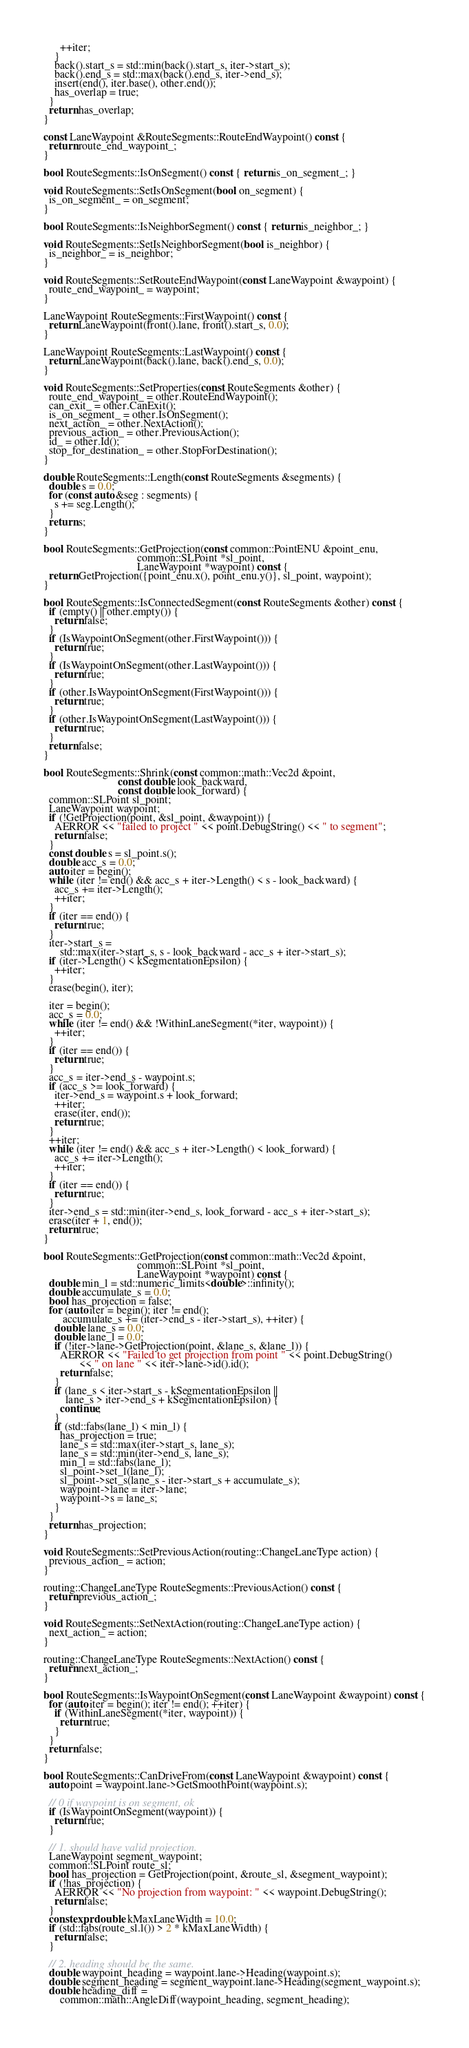<code> <loc_0><loc_0><loc_500><loc_500><_C++_>      ++iter;
    }
    back().start_s = std::min(back().start_s, iter->start_s);
    back().end_s = std::max(back().end_s, iter->end_s);
    insert(end(), iter.base(), other.end());
    has_overlap = true;
  }
  return has_overlap;
}

const LaneWaypoint &RouteSegments::RouteEndWaypoint() const {
  return route_end_waypoint_;
}

bool RouteSegments::IsOnSegment() const { return is_on_segment_; }

void RouteSegments::SetIsOnSegment(bool on_segment) {
  is_on_segment_ = on_segment;
}

bool RouteSegments::IsNeighborSegment() const { return is_neighbor_; }

void RouteSegments::SetIsNeighborSegment(bool is_neighbor) {
  is_neighbor_ = is_neighbor;
}

void RouteSegments::SetRouteEndWaypoint(const LaneWaypoint &waypoint) {
  route_end_waypoint_ = waypoint;
}

LaneWaypoint RouteSegments::FirstWaypoint() const {
  return LaneWaypoint(front().lane, front().start_s, 0.0);
}

LaneWaypoint RouteSegments::LastWaypoint() const {
  return LaneWaypoint(back().lane, back().end_s, 0.0);
}

void RouteSegments::SetProperties(const RouteSegments &other) {
  route_end_waypoint_ = other.RouteEndWaypoint();
  can_exit_ = other.CanExit();
  is_on_segment_ = other.IsOnSegment();
  next_action_ = other.NextAction();
  previous_action_ = other.PreviousAction();
  id_ = other.Id();
  stop_for_destination_ = other.StopForDestination();
}

double RouteSegments::Length(const RouteSegments &segments) {
  double s = 0.0;
  for (const auto &seg : segments) {
    s += seg.Length();
  }
  return s;
}

bool RouteSegments::GetProjection(const common::PointENU &point_enu,
                                  common::SLPoint *sl_point,
                                  LaneWaypoint *waypoint) const {
  return GetProjection({point_enu.x(), point_enu.y()}, sl_point, waypoint);
}

bool RouteSegments::IsConnectedSegment(const RouteSegments &other) const {
  if (empty() || other.empty()) {
    return false;
  }
  if (IsWaypointOnSegment(other.FirstWaypoint())) {
    return true;
  }
  if (IsWaypointOnSegment(other.LastWaypoint())) {
    return true;
  }
  if (other.IsWaypointOnSegment(FirstWaypoint())) {
    return true;
  }
  if (other.IsWaypointOnSegment(LastWaypoint())) {
    return true;
  }
  return false;
}

bool RouteSegments::Shrink(const common::math::Vec2d &point,
                           const double look_backward,
                           const double look_forward) {
  common::SLPoint sl_point;
  LaneWaypoint waypoint;
  if (!GetProjection(point, &sl_point, &waypoint)) {
    AERROR << "failed to project " << point.DebugString() << " to segment";
    return false;
  }
  const double s = sl_point.s();
  double acc_s = 0.0;
  auto iter = begin();
  while (iter != end() && acc_s + iter->Length() < s - look_backward) {
    acc_s += iter->Length();
    ++iter;
  }
  if (iter == end()) {
    return true;
  }
  iter->start_s =
      std::max(iter->start_s, s - look_backward - acc_s + iter->start_s);
  if (iter->Length() < kSegmentationEpsilon) {
    ++iter;
  }
  erase(begin(), iter);

  iter = begin();
  acc_s = 0.0;
  while (iter != end() && !WithinLaneSegment(*iter, waypoint)) {
    ++iter;
  }
  if (iter == end()) {
    return true;
  }
  acc_s = iter->end_s - waypoint.s;
  if (acc_s >= look_forward) {
    iter->end_s = waypoint.s + look_forward;
    ++iter;
    erase(iter, end());
    return true;
  }
  ++iter;
  while (iter != end() && acc_s + iter->Length() < look_forward) {
    acc_s += iter->Length();
    ++iter;
  }
  if (iter == end()) {
    return true;
  }
  iter->end_s = std::min(iter->end_s, look_forward - acc_s + iter->start_s);
  erase(iter + 1, end());
  return true;
}

bool RouteSegments::GetProjection(const common::math::Vec2d &point,
                                  common::SLPoint *sl_point,
                                  LaneWaypoint *waypoint) const {
  double min_l = std::numeric_limits<double>::infinity();
  double accumulate_s = 0.0;
  bool has_projection = false;
  for (auto iter = begin(); iter != end();
       accumulate_s += (iter->end_s - iter->start_s), ++iter) {
    double lane_s = 0.0;
    double lane_l = 0.0;
    if (!iter->lane->GetProjection(point, &lane_s, &lane_l)) {
      AERROR << "Failed to get projection from point " << point.DebugString()
             << " on lane " << iter->lane->id().id();
      return false;
    }
    if (lane_s < iter->start_s - kSegmentationEpsilon ||
        lane_s > iter->end_s + kSegmentationEpsilon) {
      continue;
    }
    if (std::fabs(lane_l) < min_l) {
      has_projection = true;
      lane_s = std::max(iter->start_s, lane_s);
      lane_s = std::min(iter->end_s, lane_s);
      min_l = std::fabs(lane_l);
      sl_point->set_l(lane_l);
      sl_point->set_s(lane_s - iter->start_s + accumulate_s);
      waypoint->lane = iter->lane;
      waypoint->s = lane_s;
    }
  }
  return has_projection;
}

void RouteSegments::SetPreviousAction(routing::ChangeLaneType action) {
  previous_action_ = action;
}

routing::ChangeLaneType RouteSegments::PreviousAction() const {
  return previous_action_;
}

void RouteSegments::SetNextAction(routing::ChangeLaneType action) {
  next_action_ = action;
}

routing::ChangeLaneType RouteSegments::NextAction() const {
  return next_action_;
}

bool RouteSegments::IsWaypointOnSegment(const LaneWaypoint &waypoint) const {
  for (auto iter = begin(); iter != end(); ++iter) {
    if (WithinLaneSegment(*iter, waypoint)) {
      return true;
    }
  }
  return false;
}

bool RouteSegments::CanDriveFrom(const LaneWaypoint &waypoint) const {
  auto point = waypoint.lane->GetSmoothPoint(waypoint.s);

  // 0 if waypoint is on segment, ok
  if (IsWaypointOnSegment(waypoint)) {
    return true;
  }

  // 1. should have valid projection.
  LaneWaypoint segment_waypoint;
  common::SLPoint route_sl;
  bool has_projection = GetProjection(point, &route_sl, &segment_waypoint);
  if (!has_projection) {
    AERROR << "No projection from waypoint: " << waypoint.DebugString();
    return false;
  }
  constexpr double kMaxLaneWidth = 10.0;
  if (std::fabs(route_sl.l()) > 2 * kMaxLaneWidth) {
    return false;
  }

  // 2. heading should be the same.
  double waypoint_heading = waypoint.lane->Heading(waypoint.s);
  double segment_heading = segment_waypoint.lane->Heading(segment_waypoint.s);
  double heading_diff =
      common::math::AngleDiff(waypoint_heading, segment_heading);</code> 